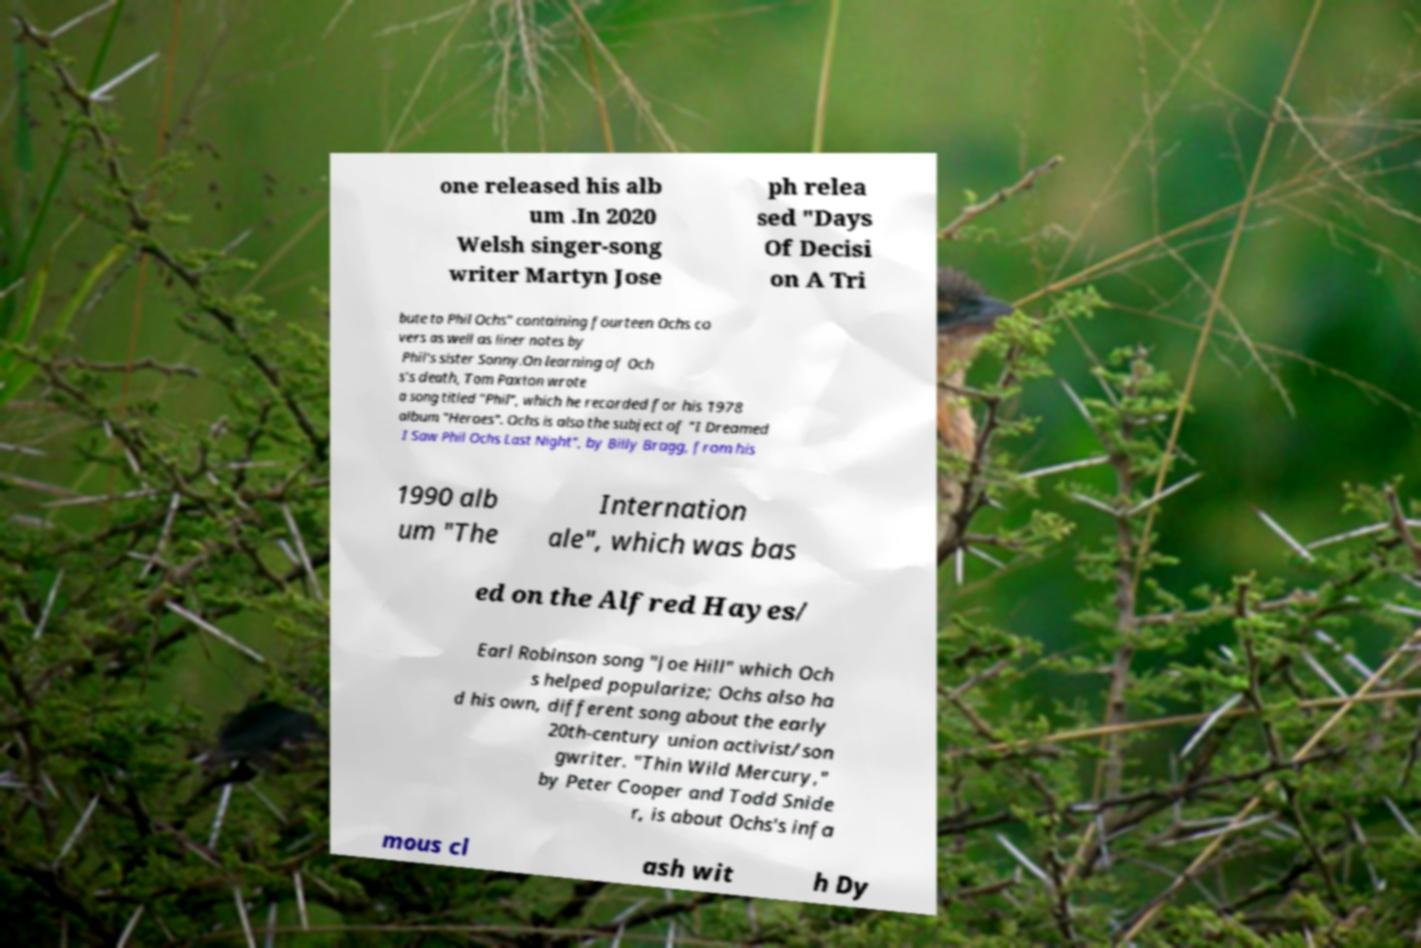There's text embedded in this image that I need extracted. Can you transcribe it verbatim? one released his alb um .In 2020 Welsh singer-song writer Martyn Jose ph relea sed "Days Of Decisi on A Tri bute to Phil Ochs" containing fourteen Ochs co vers as well as liner notes by Phil's sister Sonny.On learning of Och s's death, Tom Paxton wrote a song titled "Phil", which he recorded for his 1978 album "Heroes". Ochs is also the subject of "I Dreamed I Saw Phil Ochs Last Night", by Billy Bragg, from his 1990 alb um "The Internation ale", which was bas ed on the Alfred Hayes/ Earl Robinson song "Joe Hill" which Och s helped popularize; Ochs also ha d his own, different song about the early 20th-century union activist/son gwriter. "Thin Wild Mercury," by Peter Cooper and Todd Snide r, is about Ochs's infa mous cl ash wit h Dy 